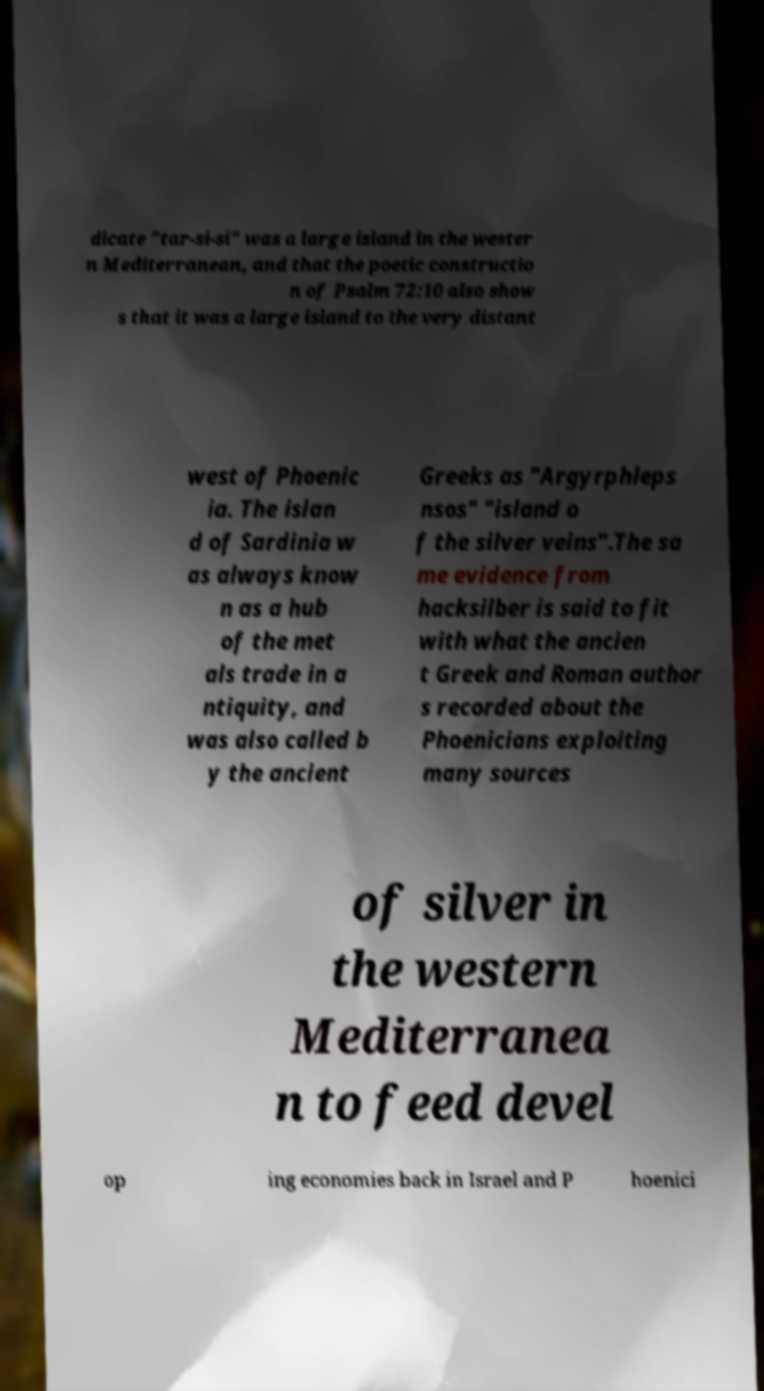What messages or text are displayed in this image? I need them in a readable, typed format. dicate "tar-si-si" was a large island in the wester n Mediterranean, and that the poetic constructio n of Psalm 72:10 also show s that it was a large island to the very distant west of Phoenic ia. The islan d of Sardinia w as always know n as a hub of the met als trade in a ntiquity, and was also called b y the ancient Greeks as "Argyrphleps nsos" "island o f the silver veins".The sa me evidence from hacksilber is said to fit with what the ancien t Greek and Roman author s recorded about the Phoenicians exploiting many sources of silver in the western Mediterranea n to feed devel op ing economies back in Israel and P hoenici 